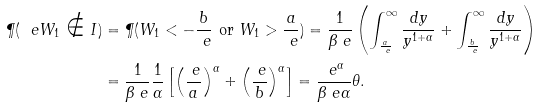Convert formula to latex. <formula><loc_0><loc_0><loc_500><loc_500>\P ( \ e W _ { 1 } \notin I ) & = \P ( W _ { 1 } < - \frac { b } { \ e } \text { or } W _ { 1 } > \frac { a } { \ e } ) = \frac { 1 } { \beta _ { \ } e } \left ( \int _ { \frac { a } { \ e } } ^ { \infty } \frac { d y } { y ^ { 1 + \alpha } } + \int _ { \frac { b } { \ e } } ^ { \infty } \frac { d y } { y ^ { 1 + \alpha } } \right ) \\ & = \frac { 1 } { \beta _ { \ } e } \frac { 1 } { \alpha } \left [ \left ( \frac { \ e } { a } \right ) ^ { \alpha } + \left ( \frac { \ e } { b } \right ) ^ { \alpha } \right ] = \frac { \ e ^ { \alpha } } { \beta _ { \ } e \alpha } \theta .</formula> 